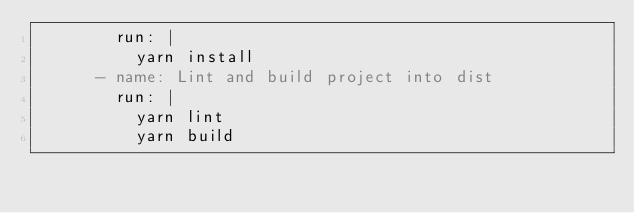Convert code to text. <code><loc_0><loc_0><loc_500><loc_500><_YAML_>        run: |
          yarn install
      - name: Lint and build project into dist
        run: |
          yarn lint
          yarn build
</code> 